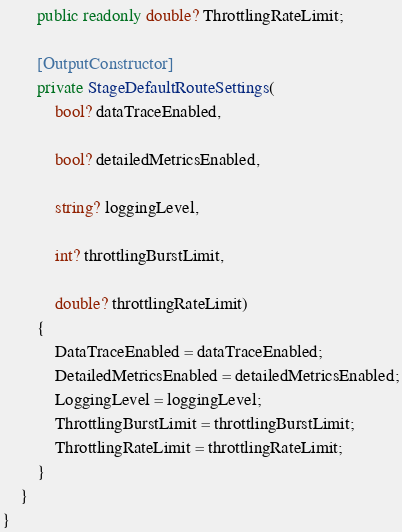Convert code to text. <code><loc_0><loc_0><loc_500><loc_500><_C#_>        public readonly double? ThrottlingRateLimit;

        [OutputConstructor]
        private StageDefaultRouteSettings(
            bool? dataTraceEnabled,

            bool? detailedMetricsEnabled,

            string? loggingLevel,

            int? throttlingBurstLimit,

            double? throttlingRateLimit)
        {
            DataTraceEnabled = dataTraceEnabled;
            DetailedMetricsEnabled = detailedMetricsEnabled;
            LoggingLevel = loggingLevel;
            ThrottlingBurstLimit = throttlingBurstLimit;
            ThrottlingRateLimit = throttlingRateLimit;
        }
    }
}
</code> 